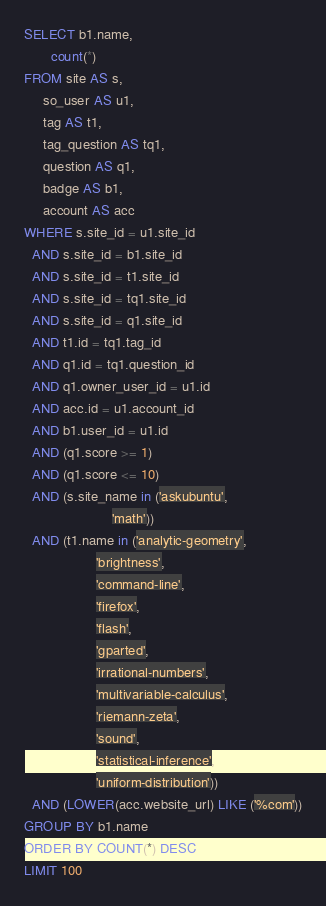Convert code to text. <code><loc_0><loc_0><loc_500><loc_500><_SQL_>SELECT b1.name,
       count(*)
FROM site AS s,
     so_user AS u1,
     tag AS t1,
     tag_question AS tq1,
     question AS q1,
     badge AS b1,
     account AS acc
WHERE s.site_id = u1.site_id
  AND s.site_id = b1.site_id
  AND s.site_id = t1.site_id
  AND s.site_id = tq1.site_id
  AND s.site_id = q1.site_id
  AND t1.id = tq1.tag_id
  AND q1.id = tq1.question_id
  AND q1.owner_user_id = u1.id
  AND acc.id = u1.account_id
  AND b1.user_id = u1.id
  AND (q1.score >= 1)
  AND (q1.score <= 10)
  AND (s.site_name in ('askubuntu',
                       'math'))
  AND (t1.name in ('analytic-geometry',
                   'brightness',
                   'command-line',
                   'firefox',
                   'flash',
                   'gparted',
                   'irrational-numbers',
                   'multivariable-calculus',
                   'riemann-zeta',
                   'sound',
                   'statistical-inference',
                   'uniform-distribution'))
  AND (LOWER(acc.website_url) LIKE ('%com'))
GROUP BY b1.name
ORDER BY COUNT(*) DESC
LIMIT 100</code> 